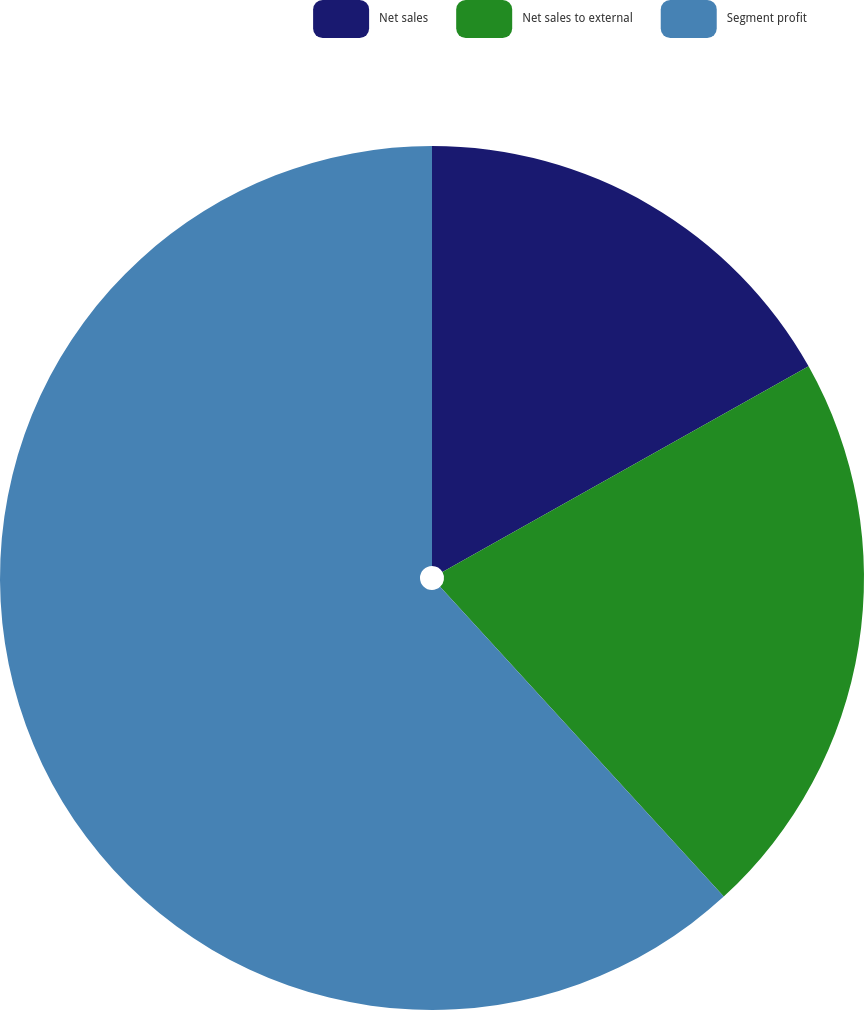Convert chart. <chart><loc_0><loc_0><loc_500><loc_500><pie_chart><fcel>Net sales<fcel>Net sales to external<fcel>Segment profit<nl><fcel>16.85%<fcel>21.35%<fcel>61.8%<nl></chart> 